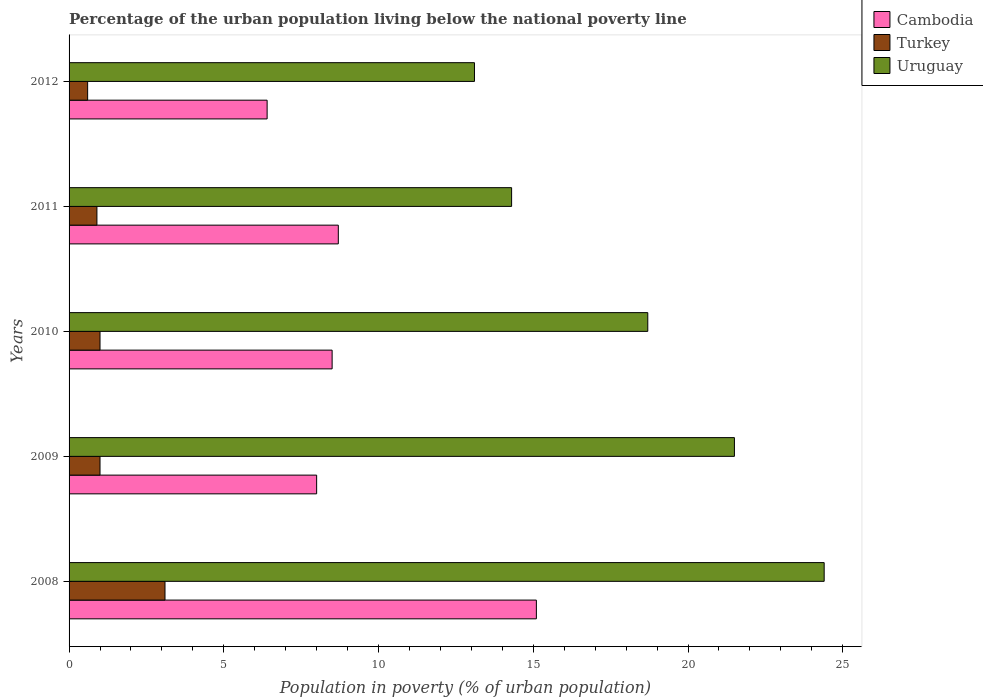Are the number of bars on each tick of the Y-axis equal?
Offer a terse response. Yes. How many bars are there on the 4th tick from the top?
Ensure brevity in your answer.  3. In which year was the percentage of the urban population living below the national poverty line in Turkey maximum?
Offer a very short reply. 2008. What is the total percentage of the urban population living below the national poverty line in Cambodia in the graph?
Your answer should be compact. 46.7. What is the difference between the percentage of the urban population living below the national poverty line in Cambodia in 2011 and that in 2012?
Your answer should be very brief. 2.3. What is the difference between the percentage of the urban population living below the national poverty line in Turkey in 2011 and the percentage of the urban population living below the national poverty line in Cambodia in 2008?
Your response must be concise. -14.2. What is the average percentage of the urban population living below the national poverty line in Cambodia per year?
Your answer should be very brief. 9.34. In the year 2010, what is the difference between the percentage of the urban population living below the national poverty line in Uruguay and percentage of the urban population living below the national poverty line in Cambodia?
Give a very brief answer. 10.2. In how many years, is the percentage of the urban population living below the national poverty line in Uruguay greater than 15 %?
Provide a short and direct response. 3. What is the ratio of the percentage of the urban population living below the national poverty line in Cambodia in 2008 to that in 2011?
Offer a very short reply. 1.74. Is the percentage of the urban population living below the national poverty line in Cambodia in 2009 less than that in 2011?
Offer a terse response. Yes. In how many years, is the percentage of the urban population living below the national poverty line in Cambodia greater than the average percentage of the urban population living below the national poverty line in Cambodia taken over all years?
Offer a very short reply. 1. Is the sum of the percentage of the urban population living below the national poverty line in Uruguay in 2011 and 2012 greater than the maximum percentage of the urban population living below the national poverty line in Cambodia across all years?
Offer a very short reply. Yes. What does the 1st bar from the top in 2009 represents?
Provide a short and direct response. Uruguay. What does the 2nd bar from the bottom in 2012 represents?
Provide a short and direct response. Turkey. Are all the bars in the graph horizontal?
Offer a terse response. Yes. How many years are there in the graph?
Your response must be concise. 5. What is the difference between two consecutive major ticks on the X-axis?
Provide a succinct answer. 5. Does the graph contain grids?
Your answer should be very brief. No. How many legend labels are there?
Make the answer very short. 3. How are the legend labels stacked?
Provide a short and direct response. Vertical. What is the title of the graph?
Your answer should be compact. Percentage of the urban population living below the national poverty line. What is the label or title of the X-axis?
Offer a terse response. Population in poverty (% of urban population). What is the Population in poverty (% of urban population) of Cambodia in 2008?
Ensure brevity in your answer.  15.1. What is the Population in poverty (% of urban population) in Uruguay in 2008?
Give a very brief answer. 24.4. What is the Population in poverty (% of urban population) of Cambodia in 2009?
Offer a very short reply. 8. What is the Population in poverty (% of urban population) in Turkey in 2009?
Offer a terse response. 1. What is the Population in poverty (% of urban population) of Turkey in 2010?
Provide a short and direct response. 1. What is the Population in poverty (% of urban population) in Uruguay in 2011?
Provide a succinct answer. 14.3. What is the Population in poverty (% of urban population) of Turkey in 2012?
Give a very brief answer. 0.6. What is the Population in poverty (% of urban population) in Uruguay in 2012?
Offer a very short reply. 13.1. Across all years, what is the maximum Population in poverty (% of urban population) of Cambodia?
Offer a very short reply. 15.1. Across all years, what is the maximum Population in poverty (% of urban population) in Turkey?
Make the answer very short. 3.1. Across all years, what is the maximum Population in poverty (% of urban population) of Uruguay?
Provide a short and direct response. 24.4. Across all years, what is the minimum Population in poverty (% of urban population) in Turkey?
Your answer should be very brief. 0.6. Across all years, what is the minimum Population in poverty (% of urban population) in Uruguay?
Keep it short and to the point. 13.1. What is the total Population in poverty (% of urban population) in Cambodia in the graph?
Provide a succinct answer. 46.7. What is the total Population in poverty (% of urban population) of Uruguay in the graph?
Make the answer very short. 92. What is the difference between the Population in poverty (% of urban population) in Cambodia in 2008 and that in 2009?
Keep it short and to the point. 7.1. What is the difference between the Population in poverty (% of urban population) of Uruguay in 2008 and that in 2009?
Make the answer very short. 2.9. What is the difference between the Population in poverty (% of urban population) of Cambodia in 2008 and that in 2010?
Provide a short and direct response. 6.6. What is the difference between the Population in poverty (% of urban population) of Cambodia in 2008 and that in 2011?
Make the answer very short. 6.4. What is the difference between the Population in poverty (% of urban population) in Turkey in 2008 and that in 2011?
Provide a short and direct response. 2.2. What is the difference between the Population in poverty (% of urban population) in Cambodia in 2008 and that in 2012?
Keep it short and to the point. 8.7. What is the difference between the Population in poverty (% of urban population) of Turkey in 2008 and that in 2012?
Keep it short and to the point. 2.5. What is the difference between the Population in poverty (% of urban population) in Cambodia in 2009 and that in 2012?
Keep it short and to the point. 1.6. What is the difference between the Population in poverty (% of urban population) of Turkey in 2009 and that in 2012?
Ensure brevity in your answer.  0.4. What is the difference between the Population in poverty (% of urban population) in Cambodia in 2010 and that in 2011?
Your answer should be compact. -0.2. What is the difference between the Population in poverty (% of urban population) of Turkey in 2010 and that in 2011?
Your response must be concise. 0.1. What is the difference between the Population in poverty (% of urban population) of Uruguay in 2011 and that in 2012?
Offer a very short reply. 1.2. What is the difference between the Population in poverty (% of urban population) of Cambodia in 2008 and the Population in poverty (% of urban population) of Uruguay in 2009?
Your answer should be compact. -6.4. What is the difference between the Population in poverty (% of urban population) of Turkey in 2008 and the Population in poverty (% of urban population) of Uruguay in 2009?
Make the answer very short. -18.4. What is the difference between the Population in poverty (% of urban population) of Cambodia in 2008 and the Population in poverty (% of urban population) of Turkey in 2010?
Ensure brevity in your answer.  14.1. What is the difference between the Population in poverty (% of urban population) in Cambodia in 2008 and the Population in poverty (% of urban population) in Uruguay in 2010?
Offer a terse response. -3.6. What is the difference between the Population in poverty (% of urban population) of Turkey in 2008 and the Population in poverty (% of urban population) of Uruguay in 2010?
Provide a succinct answer. -15.6. What is the difference between the Population in poverty (% of urban population) in Cambodia in 2008 and the Population in poverty (% of urban population) in Turkey in 2011?
Provide a succinct answer. 14.2. What is the difference between the Population in poverty (% of urban population) of Cambodia in 2008 and the Population in poverty (% of urban population) of Turkey in 2012?
Your answer should be compact. 14.5. What is the difference between the Population in poverty (% of urban population) of Cambodia in 2009 and the Population in poverty (% of urban population) of Uruguay in 2010?
Give a very brief answer. -10.7. What is the difference between the Population in poverty (% of urban population) of Turkey in 2009 and the Population in poverty (% of urban population) of Uruguay in 2010?
Make the answer very short. -17.7. What is the difference between the Population in poverty (% of urban population) of Cambodia in 2009 and the Population in poverty (% of urban population) of Turkey in 2011?
Give a very brief answer. 7.1. What is the difference between the Population in poverty (% of urban population) of Cambodia in 2009 and the Population in poverty (% of urban population) of Uruguay in 2011?
Your response must be concise. -6.3. What is the difference between the Population in poverty (% of urban population) of Turkey in 2009 and the Population in poverty (% of urban population) of Uruguay in 2011?
Provide a short and direct response. -13.3. What is the difference between the Population in poverty (% of urban population) in Cambodia in 2009 and the Population in poverty (% of urban population) in Turkey in 2012?
Your answer should be very brief. 7.4. What is the difference between the Population in poverty (% of urban population) in Cambodia in 2009 and the Population in poverty (% of urban population) in Uruguay in 2012?
Offer a very short reply. -5.1. What is the difference between the Population in poverty (% of urban population) in Cambodia in 2010 and the Population in poverty (% of urban population) in Turkey in 2011?
Offer a very short reply. 7.6. What is the difference between the Population in poverty (% of urban population) in Cambodia in 2010 and the Population in poverty (% of urban population) in Uruguay in 2011?
Give a very brief answer. -5.8. What is the difference between the Population in poverty (% of urban population) in Turkey in 2010 and the Population in poverty (% of urban population) in Uruguay in 2011?
Make the answer very short. -13.3. What is the difference between the Population in poverty (% of urban population) in Cambodia in 2010 and the Population in poverty (% of urban population) in Uruguay in 2012?
Your answer should be very brief. -4.6. What is the difference between the Population in poverty (% of urban population) in Turkey in 2010 and the Population in poverty (% of urban population) in Uruguay in 2012?
Ensure brevity in your answer.  -12.1. What is the difference between the Population in poverty (% of urban population) in Cambodia in 2011 and the Population in poverty (% of urban population) in Uruguay in 2012?
Your answer should be compact. -4.4. What is the difference between the Population in poverty (% of urban population) of Turkey in 2011 and the Population in poverty (% of urban population) of Uruguay in 2012?
Your answer should be compact. -12.2. What is the average Population in poverty (% of urban population) in Cambodia per year?
Provide a short and direct response. 9.34. What is the average Population in poverty (% of urban population) in Turkey per year?
Give a very brief answer. 1.32. In the year 2008, what is the difference between the Population in poverty (% of urban population) of Turkey and Population in poverty (% of urban population) of Uruguay?
Provide a succinct answer. -21.3. In the year 2009, what is the difference between the Population in poverty (% of urban population) of Turkey and Population in poverty (% of urban population) of Uruguay?
Offer a terse response. -20.5. In the year 2010, what is the difference between the Population in poverty (% of urban population) in Turkey and Population in poverty (% of urban population) in Uruguay?
Offer a terse response. -17.7. In the year 2011, what is the difference between the Population in poverty (% of urban population) of Cambodia and Population in poverty (% of urban population) of Turkey?
Your answer should be compact. 7.8. In the year 2011, what is the difference between the Population in poverty (% of urban population) of Cambodia and Population in poverty (% of urban population) of Uruguay?
Your answer should be compact. -5.6. In the year 2011, what is the difference between the Population in poverty (% of urban population) in Turkey and Population in poverty (% of urban population) in Uruguay?
Provide a short and direct response. -13.4. In the year 2012, what is the difference between the Population in poverty (% of urban population) of Cambodia and Population in poverty (% of urban population) of Uruguay?
Offer a terse response. -6.7. In the year 2012, what is the difference between the Population in poverty (% of urban population) of Turkey and Population in poverty (% of urban population) of Uruguay?
Give a very brief answer. -12.5. What is the ratio of the Population in poverty (% of urban population) of Cambodia in 2008 to that in 2009?
Your answer should be compact. 1.89. What is the ratio of the Population in poverty (% of urban population) in Uruguay in 2008 to that in 2009?
Your answer should be compact. 1.13. What is the ratio of the Population in poverty (% of urban population) in Cambodia in 2008 to that in 2010?
Give a very brief answer. 1.78. What is the ratio of the Population in poverty (% of urban population) in Uruguay in 2008 to that in 2010?
Your response must be concise. 1.3. What is the ratio of the Population in poverty (% of urban population) of Cambodia in 2008 to that in 2011?
Offer a very short reply. 1.74. What is the ratio of the Population in poverty (% of urban population) in Turkey in 2008 to that in 2011?
Provide a short and direct response. 3.44. What is the ratio of the Population in poverty (% of urban population) in Uruguay in 2008 to that in 2011?
Your answer should be very brief. 1.71. What is the ratio of the Population in poverty (% of urban population) in Cambodia in 2008 to that in 2012?
Your response must be concise. 2.36. What is the ratio of the Population in poverty (% of urban population) of Turkey in 2008 to that in 2012?
Provide a short and direct response. 5.17. What is the ratio of the Population in poverty (% of urban population) of Uruguay in 2008 to that in 2012?
Keep it short and to the point. 1.86. What is the ratio of the Population in poverty (% of urban population) in Uruguay in 2009 to that in 2010?
Keep it short and to the point. 1.15. What is the ratio of the Population in poverty (% of urban population) in Cambodia in 2009 to that in 2011?
Offer a terse response. 0.92. What is the ratio of the Population in poverty (% of urban population) in Turkey in 2009 to that in 2011?
Provide a short and direct response. 1.11. What is the ratio of the Population in poverty (% of urban population) in Uruguay in 2009 to that in 2011?
Offer a very short reply. 1.5. What is the ratio of the Population in poverty (% of urban population) in Turkey in 2009 to that in 2012?
Offer a terse response. 1.67. What is the ratio of the Population in poverty (% of urban population) in Uruguay in 2009 to that in 2012?
Your response must be concise. 1.64. What is the ratio of the Population in poverty (% of urban population) of Turkey in 2010 to that in 2011?
Your response must be concise. 1.11. What is the ratio of the Population in poverty (% of urban population) in Uruguay in 2010 to that in 2011?
Make the answer very short. 1.31. What is the ratio of the Population in poverty (% of urban population) in Cambodia in 2010 to that in 2012?
Keep it short and to the point. 1.33. What is the ratio of the Population in poverty (% of urban population) of Uruguay in 2010 to that in 2012?
Keep it short and to the point. 1.43. What is the ratio of the Population in poverty (% of urban population) in Cambodia in 2011 to that in 2012?
Your answer should be very brief. 1.36. What is the ratio of the Population in poverty (% of urban population) of Turkey in 2011 to that in 2012?
Offer a terse response. 1.5. What is the ratio of the Population in poverty (% of urban population) of Uruguay in 2011 to that in 2012?
Provide a short and direct response. 1.09. What is the difference between the highest and the second highest Population in poverty (% of urban population) of Cambodia?
Offer a terse response. 6.4. What is the difference between the highest and the lowest Population in poverty (% of urban population) in Cambodia?
Keep it short and to the point. 8.7. What is the difference between the highest and the lowest Population in poverty (% of urban population) in Turkey?
Keep it short and to the point. 2.5. 